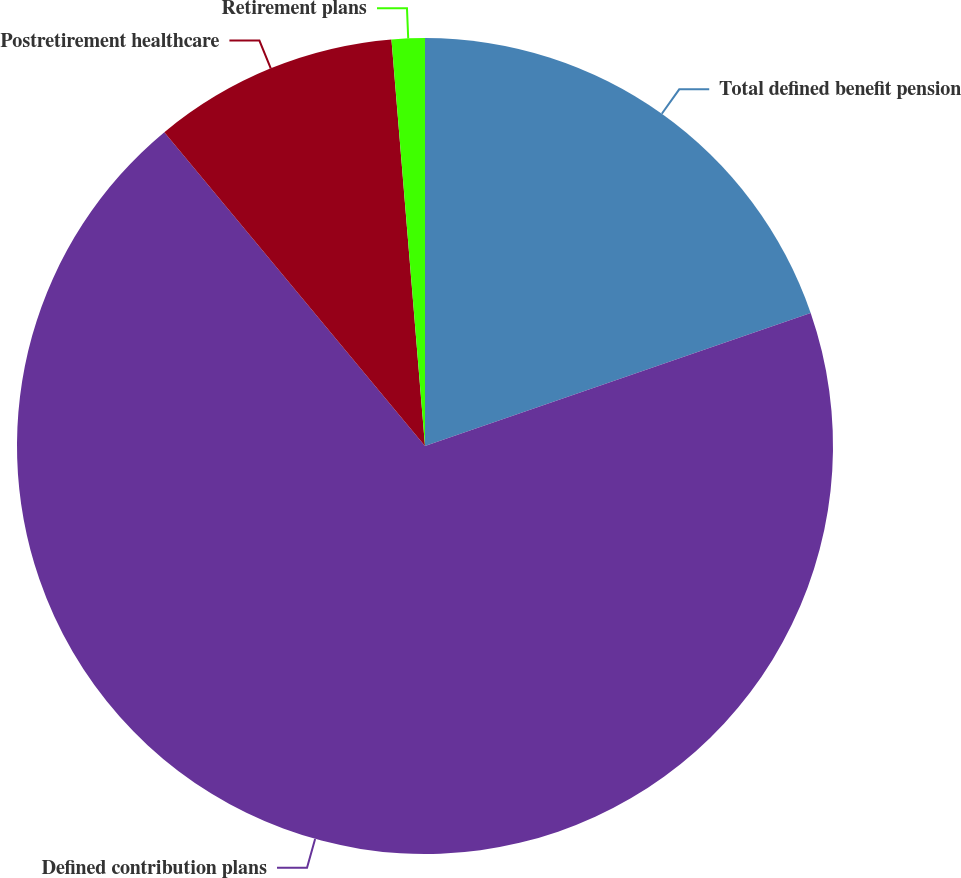Convert chart to OTSL. <chart><loc_0><loc_0><loc_500><loc_500><pie_chart><fcel>Total defined benefit pension<fcel>Defined contribution plans<fcel>Postretirement healthcare<fcel>Retirement plans<nl><fcel>19.71%<fcel>69.25%<fcel>9.72%<fcel>1.31%<nl></chart> 